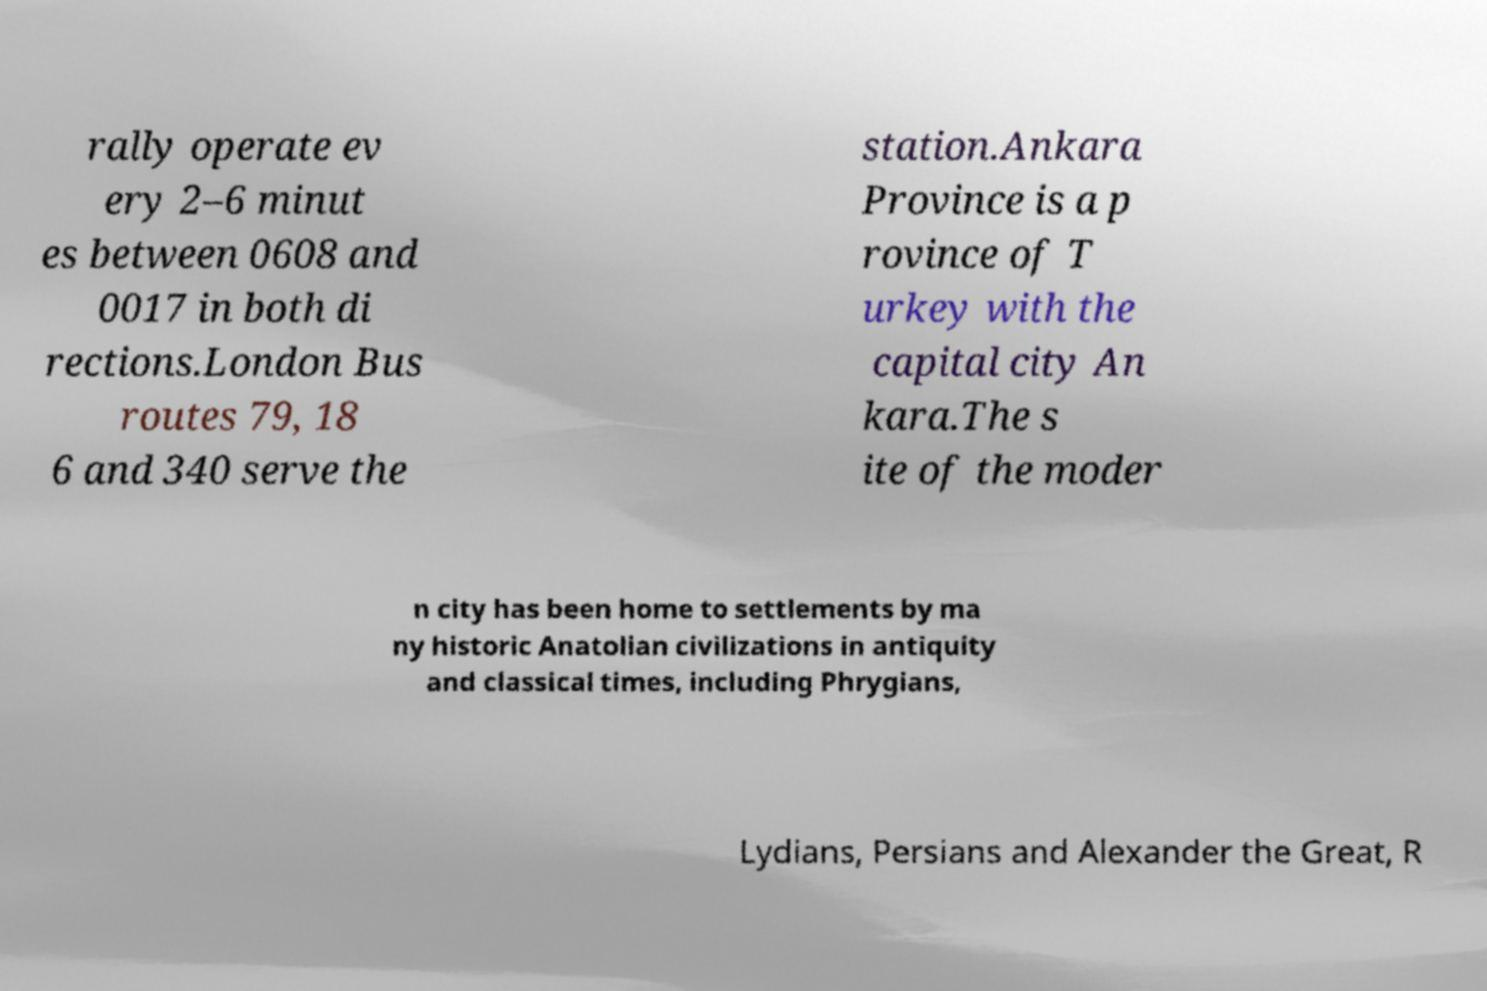Could you assist in decoding the text presented in this image and type it out clearly? rally operate ev ery 2–6 minut es between 0608 and 0017 in both di rections.London Bus routes 79, 18 6 and 340 serve the station.Ankara Province is a p rovince of T urkey with the capital city An kara.The s ite of the moder n city has been home to settlements by ma ny historic Anatolian civilizations in antiquity and classical times, including Phrygians, Lydians, Persians and Alexander the Great, R 